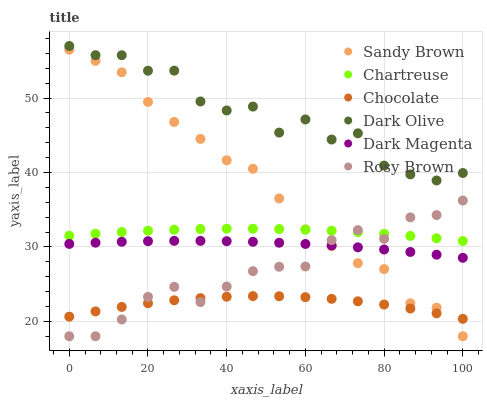Does Chocolate have the minimum area under the curve?
Answer yes or no. Yes. Does Dark Olive have the maximum area under the curve?
Answer yes or no. Yes. Does Dark Magenta have the minimum area under the curve?
Answer yes or no. No. Does Dark Magenta have the maximum area under the curve?
Answer yes or no. No. Is Dark Magenta the smoothest?
Answer yes or no. Yes. Is Dark Olive the roughest?
Answer yes or no. Yes. Is Dark Olive the smoothest?
Answer yes or no. No. Is Dark Magenta the roughest?
Answer yes or no. No. Does Rosy Brown have the lowest value?
Answer yes or no. Yes. Does Dark Magenta have the lowest value?
Answer yes or no. No. Does Dark Olive have the highest value?
Answer yes or no. Yes. Does Dark Magenta have the highest value?
Answer yes or no. No. Is Dark Magenta less than Dark Olive?
Answer yes or no. Yes. Is Dark Olive greater than Dark Magenta?
Answer yes or no. Yes. Does Rosy Brown intersect Dark Magenta?
Answer yes or no. Yes. Is Rosy Brown less than Dark Magenta?
Answer yes or no. No. Is Rosy Brown greater than Dark Magenta?
Answer yes or no. No. Does Dark Magenta intersect Dark Olive?
Answer yes or no. No. 